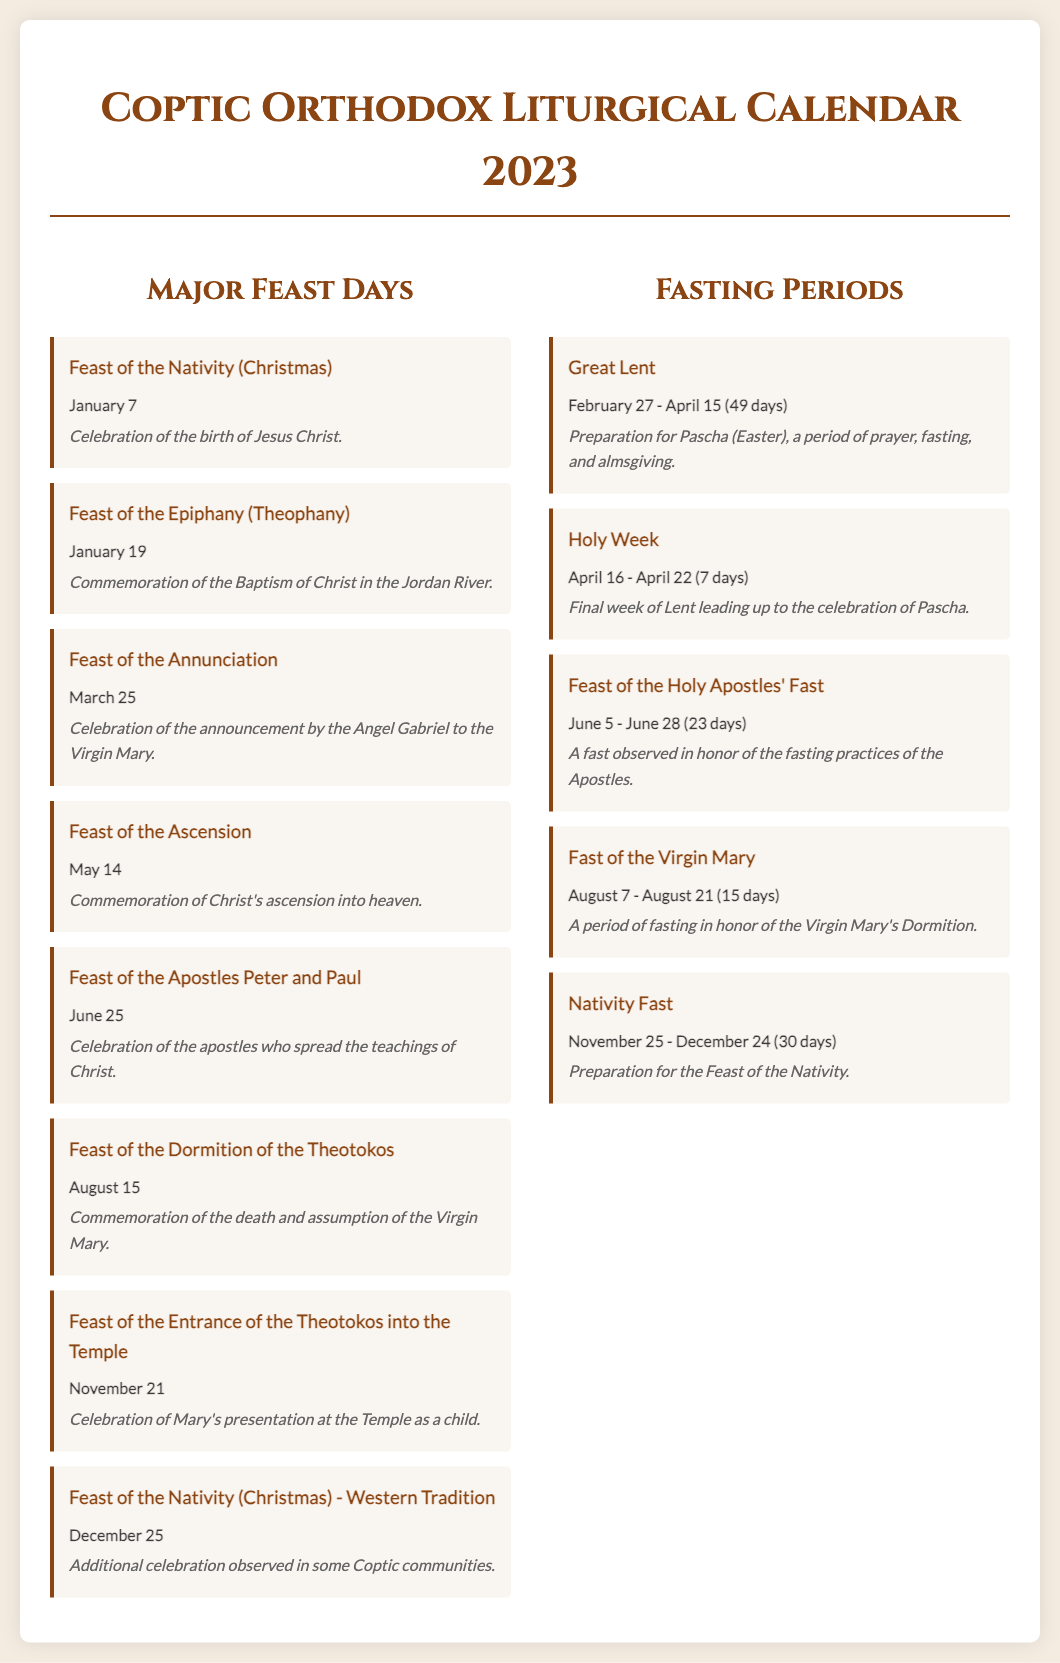What is the date of the Feast of the Nativity? The date of the Feast of the Nativity is mentioned as January 7 in the document.
Answer: January 7 What is the significance of the Feast of the Ascension? The document states that it commemorates Christ's ascension into heaven.
Answer: Commemoration of Christ's ascension into heaven How long does Great Lent last? The document specifies that Great Lent lasts for 49 days from February 27 to April 15.
Answer: 49 days What feast is celebrated on November 21? The document lists the Feast of the Entrance of the Theotokos into the Temple as the feast celebrated on that date.
Answer: Feast of the Entrance of the Theotokos into the Temple During which period does the Nativity Fast occur? The document states that the Nativity Fast occurs from November 25 to December 24.
Answer: November 25 - December 24 Which feast commemorates the death and assumption of the Virgin Mary? The document identifies the Feast of the Dormition of the Theotokos as commemorating this event.
Answer: Feast of the Dormition of the Theotokos What fasting period precedes Pascha? The document specifies that Holy Week, which lasts for 7 days, precedes the celebration of Pascha.
Answer: Holy Week What is the duration of the Fast of the Virgin Mary? According to the document, the Fast of the Virgin Mary lasts for 15 days from August 7 to August 21.
Answer: 15 days 